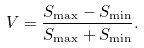<formula> <loc_0><loc_0><loc_500><loc_500>V = \frac { S _ { \max } - S _ { \min } } { S _ { \max } + S _ { \min } } .</formula> 